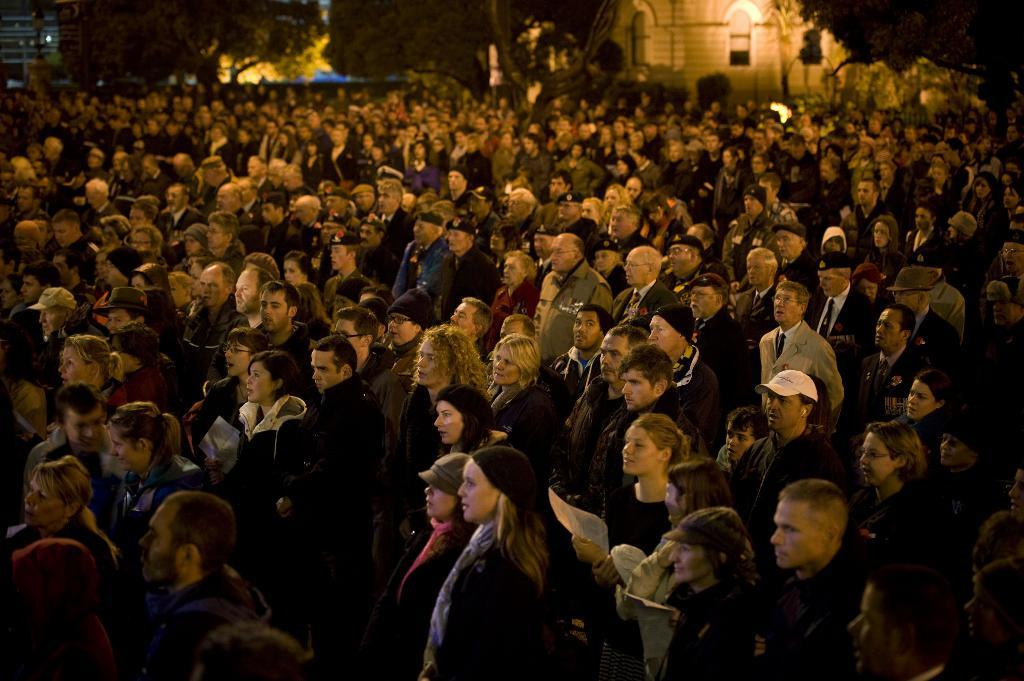How many individuals are present in the image? There are many people in the image. What are the people doing in the image? The people are standing. What are the people wearing in the image? The people are wearing clothes. Are there any people wearing additional headwear in the image? Yes, some people are wearing caps. What type of natural elements can be seen in the image? There are trees in the image. What type of man-made structures can be seen in the image? There are buildings in the image. How many cows are grazing in the image? There are no cows present in the image. What rule is being enforced by the people in the image? There is no indication of a rule being enforced in the image. 